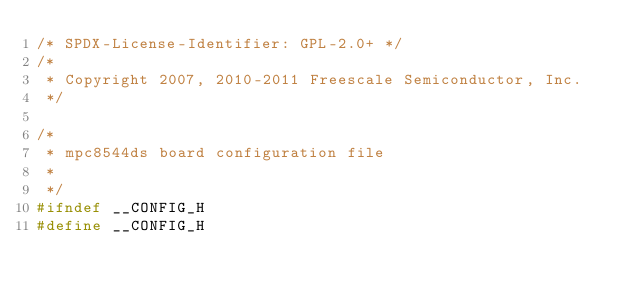Convert code to text. <code><loc_0><loc_0><loc_500><loc_500><_C_>/* SPDX-License-Identifier: GPL-2.0+ */
/*
 * Copyright 2007, 2010-2011 Freescale Semiconductor, Inc.
 */

/*
 * mpc8544ds board configuration file
 *
 */
#ifndef __CONFIG_H
#define __CONFIG_H
</code> 